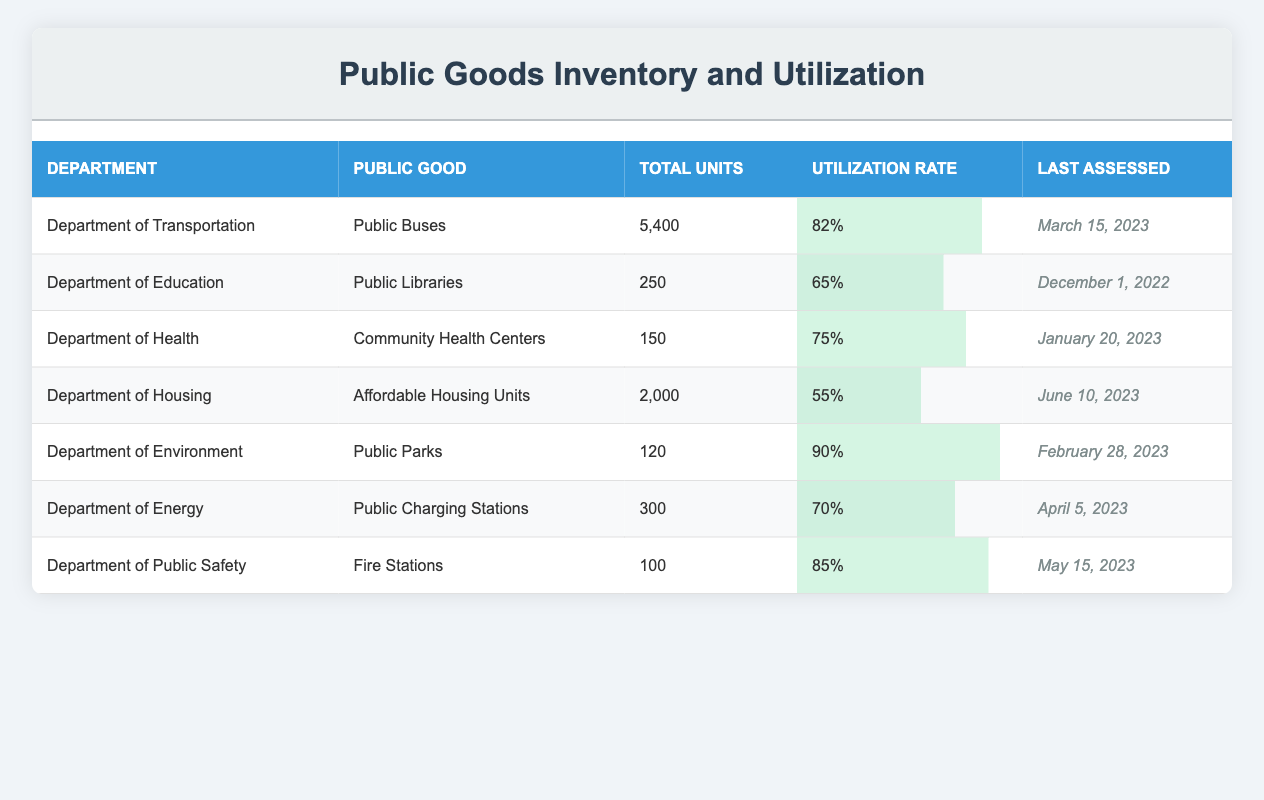What is the total number of Public Buses available in the Department of Transportation? The table shows that the Department of Transportation has a total of 5,400 Public Buses listed in the "Total Units" column.
Answer: 5,400 Which public good has the highest utilization rate? Looking at the "Utilization Rate" column, Public Parks from the Department of Environment has the highest utilization rate at 90%.
Answer: Public Parks How many total units of public goods are there across all departments? To find the total, we add the units: 5400 (Buses) + 250 (Libraries) + 150 (Health Centers) + 2000 (Housing Units) + 120 (Parks) + 300 (Charging Stations) + 100 (Fire Stations) = 6,750 total units.
Answer: 6,750 Is the utilization rate of Community Health Centers greater than that of Affordable Housing Units? The utilization rate of Community Health Centers is 75%, while Affordable Housing Units have a rate of 55%. Since 75% is greater than 55%, the statement is true.
Answer: Yes What is the average utilization rate of public goods across all departments? To calculate the average, we sum the utilization rates: 0.82 + 0.65 + 0.75 + 0.55 + 0.90 + 0.70 + 0.85 = 5.52. Then we divide by the number of departments (7): 5.52 / 7 = 0.78857, which rounds to approximately 0.79 or 79%.
Answer: 79% Which department has the lowest total units of public goods? By reviewing the "Total Units" column, the Department of Health has the lowest total with only 150 Community Health Centers.
Answer: Department of Health Is there any public good with a utilization rate of more than 85%? Upon checking the utilization rates, we see that Public Parks (90%) and Fire Stations (85%) have rates greater than or equal to 85%. Therefore, the answer is yes.
Answer: Yes What is the percentage difference in utilization between Public Buses and Public Libraries? The utilization rate for Public Buses is 82% and for Public Libraries is 65%. To find the percentage difference, calculate 82% - 65% = 17%.
Answer: 17% 